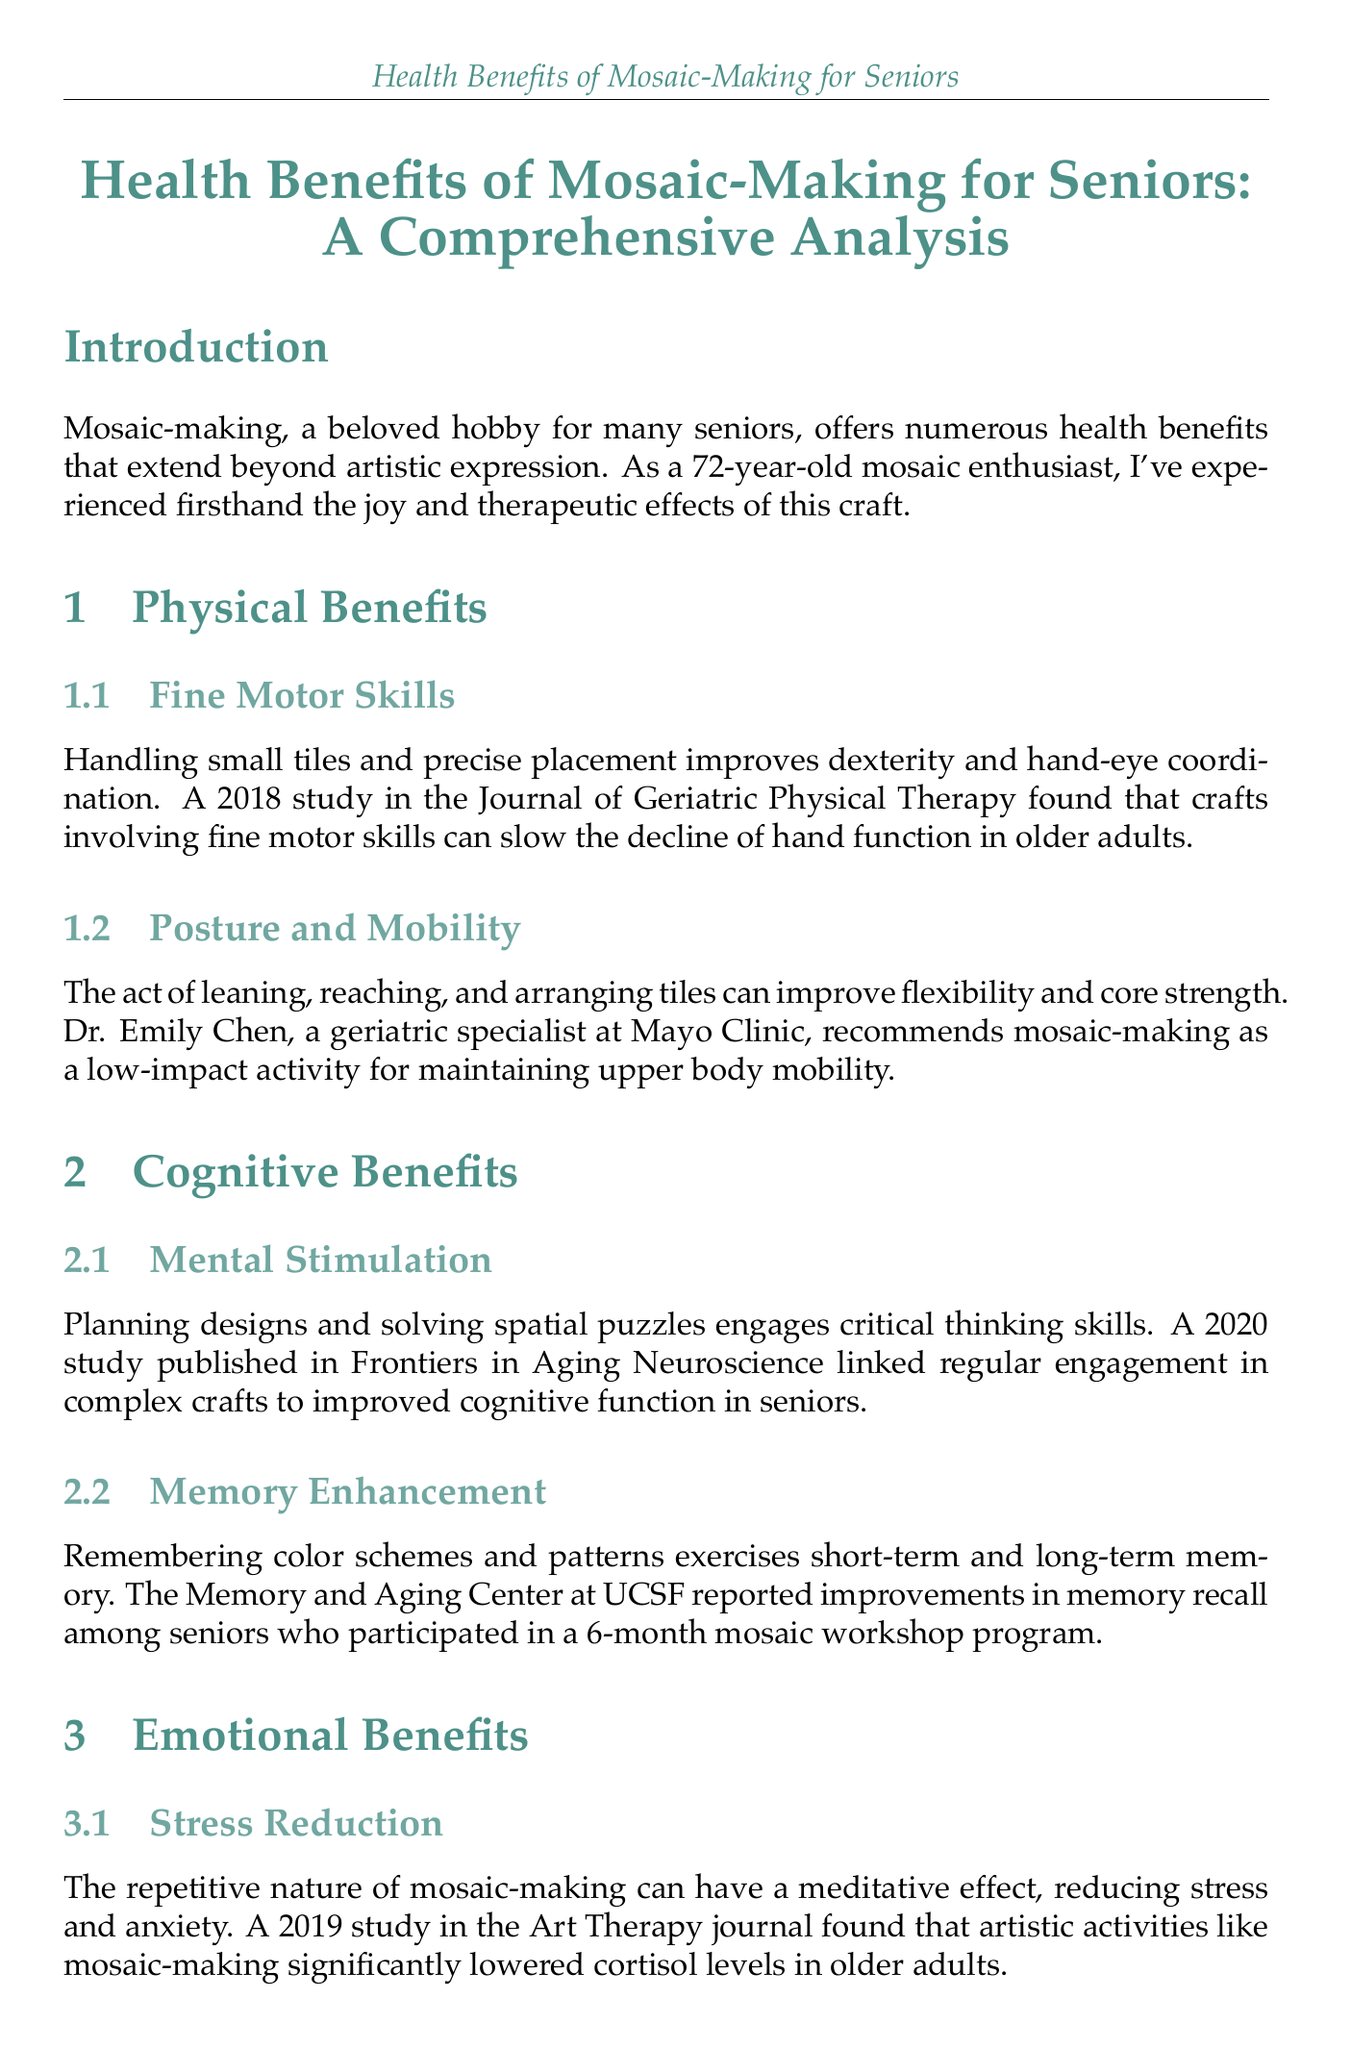what is the title of the document? The title is explicitly stated at the beginning of the document.
Answer: Health Benefits of Mosaic-Making for Seniors: A Comprehensive Analysis who conducted a study on fine motor skills in older adults? The document cites a specific study that pertains to fine motor skills.
Answer: Journal of Geriatric Physical Therapy what year was the mental stimulation study published? The document provides the publication year for the study on mental stimulation.
Answer: 2020 who emphasizes the importance of social engagement in preventing depression in seniors? An expert opinion is included in the document regarding social engagement.
Answer: Dr. Sarah Thompson what are adaptive tools mentioned for seniors? The document lists examples of tools designed to help seniors with mosaic-making.
Answer: easy-grip nippers and magnifying glasses what is a physical benefit of mosaic-making related to posture? The document discusses how mosaic-making affects physical health, particularly posture.
Answer: improve flexibility and core strength what is the repetitive nature of mosaic-making said to reduce? The document discusses emotional benefits linked to mosaic-making.
Answer: stress and anxiety how long was the mosaic workshop program mentioned for memory enhancement? The document specifies the duration of the workshop program that facilitated memory improvement.
Answer: 6-month what type of analysis does the report provide? The document outlines the scope and nature of the study on mosaic-making benefits for seniors.
Answer: Comprehensive Analysis 